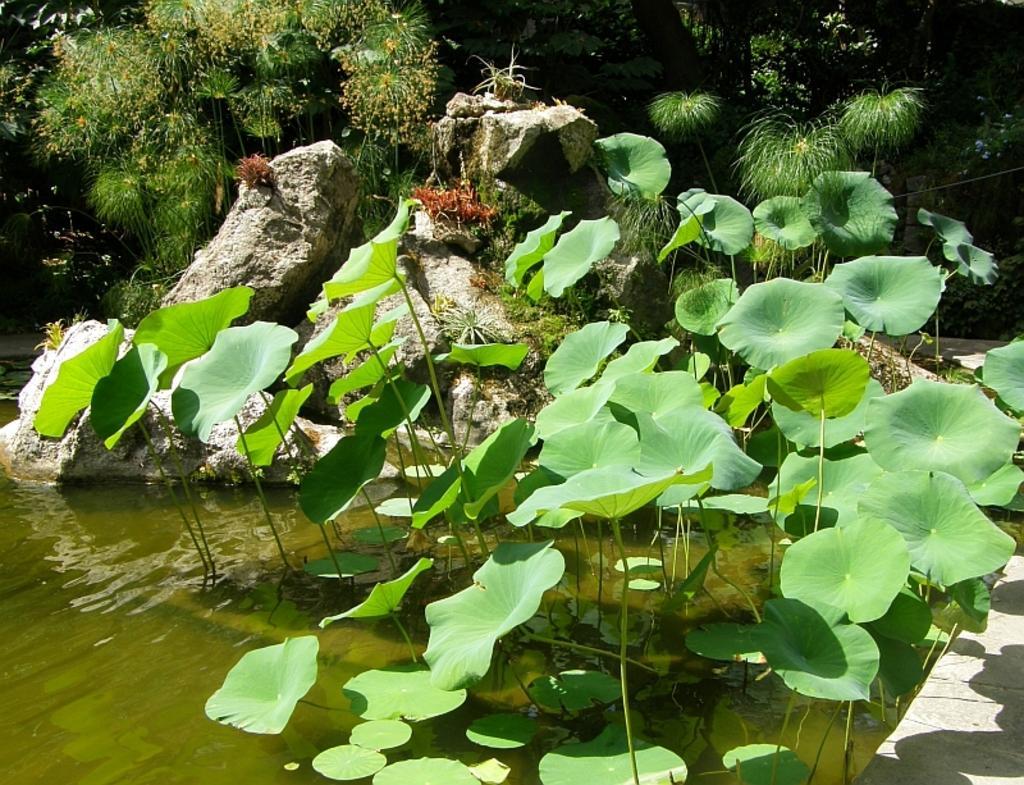Could you give a brief overview of what you see in this image? In this image, we can see some green color leaves, there is water, in the background there are some green color plants. 